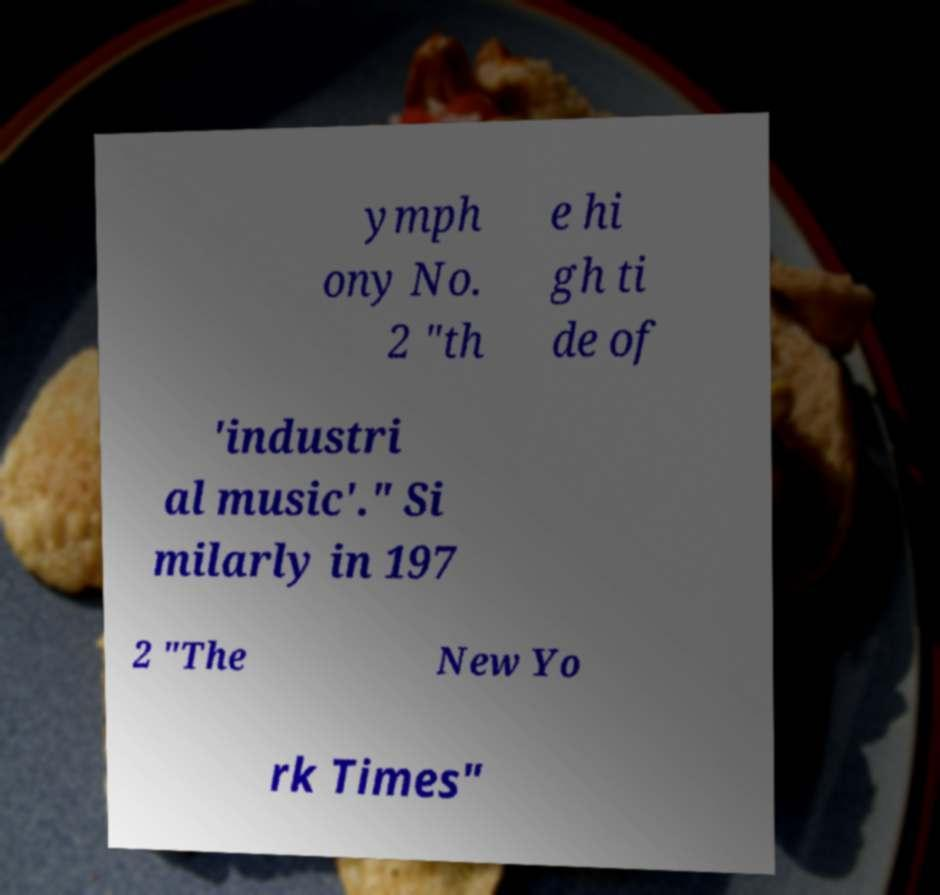What messages or text are displayed in this image? I need them in a readable, typed format. ymph ony No. 2 "th e hi gh ti de of 'industri al music'." Si milarly in 197 2 "The New Yo rk Times" 